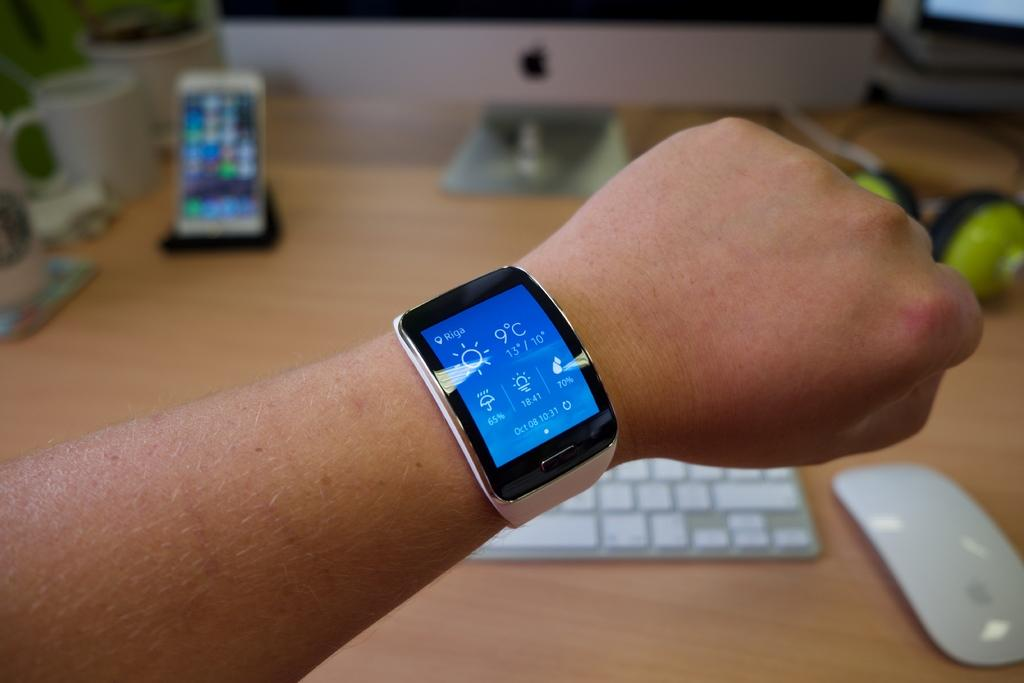Provide a one-sentence caption for the provided image. October 08, 10:31 and 9 degrees are displayed on this smart watch. 